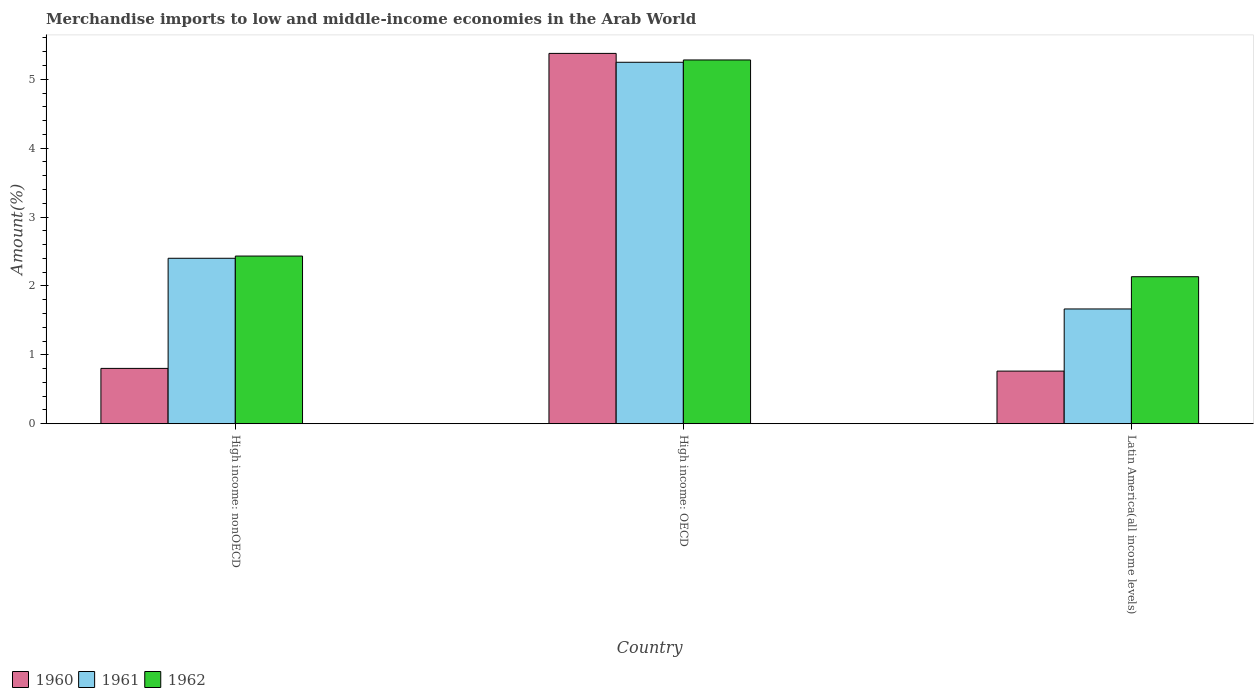How many different coloured bars are there?
Provide a short and direct response. 3. How many bars are there on the 3rd tick from the left?
Your answer should be very brief. 3. How many bars are there on the 3rd tick from the right?
Keep it short and to the point. 3. What is the label of the 2nd group of bars from the left?
Your response must be concise. High income: OECD. In how many cases, is the number of bars for a given country not equal to the number of legend labels?
Offer a terse response. 0. What is the percentage of amount earned from merchandise imports in 1962 in Latin America(all income levels)?
Keep it short and to the point. 2.13. Across all countries, what is the maximum percentage of amount earned from merchandise imports in 1962?
Give a very brief answer. 5.28. Across all countries, what is the minimum percentage of amount earned from merchandise imports in 1962?
Provide a succinct answer. 2.13. In which country was the percentage of amount earned from merchandise imports in 1962 maximum?
Ensure brevity in your answer.  High income: OECD. In which country was the percentage of amount earned from merchandise imports in 1960 minimum?
Provide a succinct answer. Latin America(all income levels). What is the total percentage of amount earned from merchandise imports in 1962 in the graph?
Provide a succinct answer. 9.85. What is the difference between the percentage of amount earned from merchandise imports in 1962 in High income: OECD and that in Latin America(all income levels)?
Offer a terse response. 3.15. What is the difference between the percentage of amount earned from merchandise imports in 1962 in Latin America(all income levels) and the percentage of amount earned from merchandise imports in 1961 in High income: OECD?
Offer a terse response. -3.11. What is the average percentage of amount earned from merchandise imports in 1960 per country?
Keep it short and to the point. 2.31. What is the difference between the percentage of amount earned from merchandise imports of/in 1960 and percentage of amount earned from merchandise imports of/in 1961 in Latin America(all income levels)?
Ensure brevity in your answer.  -0.9. In how many countries, is the percentage of amount earned from merchandise imports in 1961 greater than 4.6 %?
Give a very brief answer. 1. What is the ratio of the percentage of amount earned from merchandise imports in 1960 in High income: nonOECD to that in Latin America(all income levels)?
Your response must be concise. 1.05. Is the difference between the percentage of amount earned from merchandise imports in 1960 in High income: OECD and High income: nonOECD greater than the difference between the percentage of amount earned from merchandise imports in 1961 in High income: OECD and High income: nonOECD?
Offer a terse response. Yes. What is the difference between the highest and the second highest percentage of amount earned from merchandise imports in 1962?
Give a very brief answer. 0.3. What is the difference between the highest and the lowest percentage of amount earned from merchandise imports in 1961?
Your answer should be very brief. 3.58. What does the 3rd bar from the left in High income: OECD represents?
Give a very brief answer. 1962. What does the 2nd bar from the right in Latin America(all income levels) represents?
Provide a succinct answer. 1961. Is it the case that in every country, the sum of the percentage of amount earned from merchandise imports in 1961 and percentage of amount earned from merchandise imports in 1960 is greater than the percentage of amount earned from merchandise imports in 1962?
Your response must be concise. Yes. How many bars are there?
Make the answer very short. 9. How many countries are there in the graph?
Your answer should be compact. 3. Are the values on the major ticks of Y-axis written in scientific E-notation?
Offer a terse response. No. Does the graph contain any zero values?
Your response must be concise. No. Does the graph contain grids?
Offer a terse response. No. How many legend labels are there?
Provide a succinct answer. 3. How are the legend labels stacked?
Make the answer very short. Horizontal. What is the title of the graph?
Ensure brevity in your answer.  Merchandise imports to low and middle-income economies in the Arab World. Does "1983" appear as one of the legend labels in the graph?
Provide a succinct answer. No. What is the label or title of the X-axis?
Ensure brevity in your answer.  Country. What is the label or title of the Y-axis?
Ensure brevity in your answer.  Amount(%). What is the Amount(%) in 1960 in High income: nonOECD?
Your response must be concise. 0.8. What is the Amount(%) in 1961 in High income: nonOECD?
Offer a very short reply. 2.4. What is the Amount(%) in 1962 in High income: nonOECD?
Your answer should be compact. 2.43. What is the Amount(%) in 1960 in High income: OECD?
Keep it short and to the point. 5.38. What is the Amount(%) in 1961 in High income: OECD?
Offer a very short reply. 5.25. What is the Amount(%) in 1962 in High income: OECD?
Provide a short and direct response. 5.28. What is the Amount(%) in 1960 in Latin America(all income levels)?
Your response must be concise. 0.76. What is the Amount(%) of 1961 in Latin America(all income levels)?
Give a very brief answer. 1.67. What is the Amount(%) of 1962 in Latin America(all income levels)?
Give a very brief answer. 2.13. Across all countries, what is the maximum Amount(%) of 1960?
Make the answer very short. 5.38. Across all countries, what is the maximum Amount(%) in 1961?
Offer a terse response. 5.25. Across all countries, what is the maximum Amount(%) in 1962?
Your answer should be compact. 5.28. Across all countries, what is the minimum Amount(%) in 1960?
Provide a short and direct response. 0.76. Across all countries, what is the minimum Amount(%) in 1961?
Give a very brief answer. 1.67. Across all countries, what is the minimum Amount(%) of 1962?
Provide a short and direct response. 2.13. What is the total Amount(%) of 1960 in the graph?
Make the answer very short. 6.94. What is the total Amount(%) of 1961 in the graph?
Provide a short and direct response. 9.31. What is the total Amount(%) in 1962 in the graph?
Your answer should be compact. 9.85. What is the difference between the Amount(%) of 1960 in High income: nonOECD and that in High income: OECD?
Provide a succinct answer. -4.57. What is the difference between the Amount(%) of 1961 in High income: nonOECD and that in High income: OECD?
Give a very brief answer. -2.84. What is the difference between the Amount(%) in 1962 in High income: nonOECD and that in High income: OECD?
Provide a succinct answer. -2.85. What is the difference between the Amount(%) of 1960 in High income: nonOECD and that in Latin America(all income levels)?
Your response must be concise. 0.04. What is the difference between the Amount(%) in 1961 in High income: nonOECD and that in Latin America(all income levels)?
Provide a succinct answer. 0.74. What is the difference between the Amount(%) in 1962 in High income: nonOECD and that in Latin America(all income levels)?
Provide a succinct answer. 0.3. What is the difference between the Amount(%) of 1960 in High income: OECD and that in Latin America(all income levels)?
Your answer should be compact. 4.61. What is the difference between the Amount(%) of 1961 in High income: OECD and that in Latin America(all income levels)?
Keep it short and to the point. 3.58. What is the difference between the Amount(%) of 1962 in High income: OECD and that in Latin America(all income levels)?
Your answer should be very brief. 3.15. What is the difference between the Amount(%) in 1960 in High income: nonOECD and the Amount(%) in 1961 in High income: OECD?
Your response must be concise. -4.44. What is the difference between the Amount(%) of 1960 in High income: nonOECD and the Amount(%) of 1962 in High income: OECD?
Your answer should be very brief. -4.48. What is the difference between the Amount(%) of 1961 in High income: nonOECD and the Amount(%) of 1962 in High income: OECD?
Keep it short and to the point. -2.88. What is the difference between the Amount(%) of 1960 in High income: nonOECD and the Amount(%) of 1961 in Latin America(all income levels)?
Keep it short and to the point. -0.86. What is the difference between the Amount(%) of 1960 in High income: nonOECD and the Amount(%) of 1962 in Latin America(all income levels)?
Give a very brief answer. -1.33. What is the difference between the Amount(%) of 1961 in High income: nonOECD and the Amount(%) of 1962 in Latin America(all income levels)?
Offer a very short reply. 0.27. What is the difference between the Amount(%) of 1960 in High income: OECD and the Amount(%) of 1961 in Latin America(all income levels)?
Your answer should be compact. 3.71. What is the difference between the Amount(%) in 1960 in High income: OECD and the Amount(%) in 1962 in Latin America(all income levels)?
Provide a succinct answer. 3.24. What is the difference between the Amount(%) of 1961 in High income: OECD and the Amount(%) of 1962 in Latin America(all income levels)?
Provide a succinct answer. 3.11. What is the average Amount(%) of 1960 per country?
Keep it short and to the point. 2.31. What is the average Amount(%) in 1961 per country?
Your answer should be compact. 3.1. What is the average Amount(%) of 1962 per country?
Give a very brief answer. 3.28. What is the difference between the Amount(%) of 1960 and Amount(%) of 1961 in High income: nonOECD?
Give a very brief answer. -1.6. What is the difference between the Amount(%) in 1960 and Amount(%) in 1962 in High income: nonOECD?
Your response must be concise. -1.63. What is the difference between the Amount(%) of 1961 and Amount(%) of 1962 in High income: nonOECD?
Make the answer very short. -0.03. What is the difference between the Amount(%) of 1960 and Amount(%) of 1961 in High income: OECD?
Offer a terse response. 0.13. What is the difference between the Amount(%) in 1960 and Amount(%) in 1962 in High income: OECD?
Provide a short and direct response. 0.1. What is the difference between the Amount(%) in 1961 and Amount(%) in 1962 in High income: OECD?
Make the answer very short. -0.03. What is the difference between the Amount(%) of 1960 and Amount(%) of 1961 in Latin America(all income levels)?
Ensure brevity in your answer.  -0.9. What is the difference between the Amount(%) in 1960 and Amount(%) in 1962 in Latin America(all income levels)?
Your answer should be compact. -1.37. What is the difference between the Amount(%) of 1961 and Amount(%) of 1962 in Latin America(all income levels)?
Provide a short and direct response. -0.47. What is the ratio of the Amount(%) in 1960 in High income: nonOECD to that in High income: OECD?
Offer a terse response. 0.15. What is the ratio of the Amount(%) of 1961 in High income: nonOECD to that in High income: OECD?
Ensure brevity in your answer.  0.46. What is the ratio of the Amount(%) of 1962 in High income: nonOECD to that in High income: OECD?
Keep it short and to the point. 0.46. What is the ratio of the Amount(%) in 1960 in High income: nonOECD to that in Latin America(all income levels)?
Your answer should be compact. 1.05. What is the ratio of the Amount(%) in 1961 in High income: nonOECD to that in Latin America(all income levels)?
Give a very brief answer. 1.44. What is the ratio of the Amount(%) of 1962 in High income: nonOECD to that in Latin America(all income levels)?
Ensure brevity in your answer.  1.14. What is the ratio of the Amount(%) in 1960 in High income: OECD to that in Latin America(all income levels)?
Give a very brief answer. 7.04. What is the ratio of the Amount(%) in 1961 in High income: OECD to that in Latin America(all income levels)?
Your response must be concise. 3.15. What is the ratio of the Amount(%) of 1962 in High income: OECD to that in Latin America(all income levels)?
Give a very brief answer. 2.47. What is the difference between the highest and the second highest Amount(%) in 1960?
Give a very brief answer. 4.57. What is the difference between the highest and the second highest Amount(%) of 1961?
Keep it short and to the point. 2.84. What is the difference between the highest and the second highest Amount(%) in 1962?
Ensure brevity in your answer.  2.85. What is the difference between the highest and the lowest Amount(%) in 1960?
Keep it short and to the point. 4.61. What is the difference between the highest and the lowest Amount(%) of 1961?
Offer a very short reply. 3.58. What is the difference between the highest and the lowest Amount(%) in 1962?
Your answer should be compact. 3.15. 